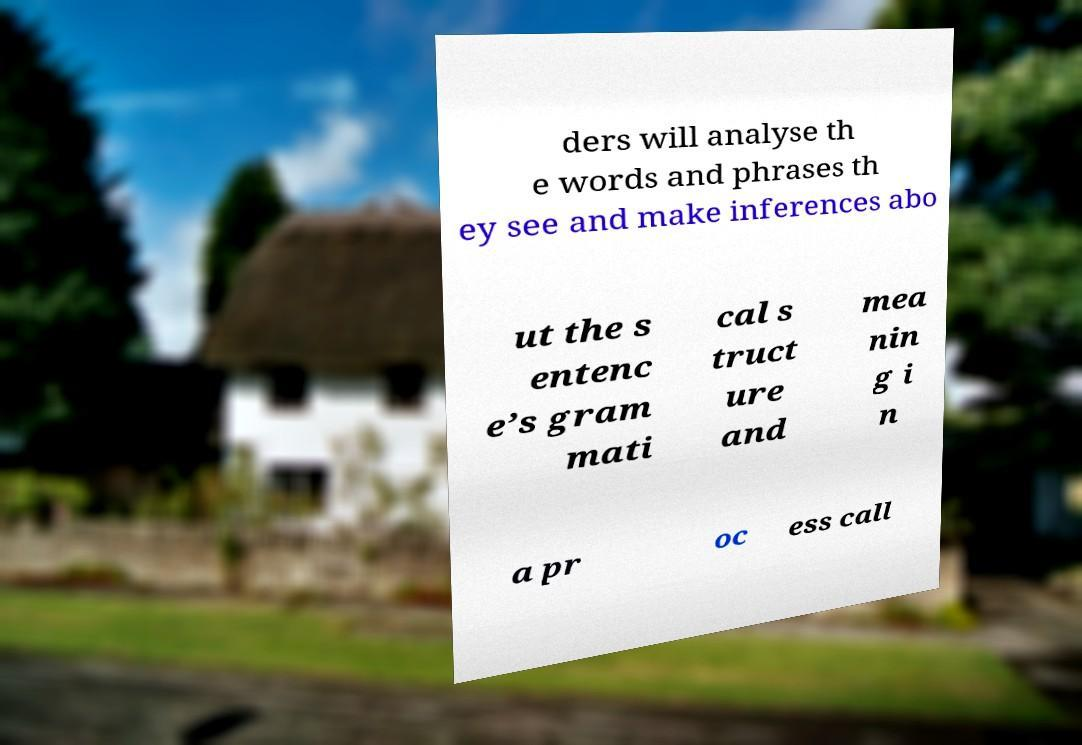Could you extract and type out the text from this image? ders will analyse th e words and phrases th ey see and make inferences abo ut the s entenc e’s gram mati cal s truct ure and mea nin g i n a pr oc ess call 